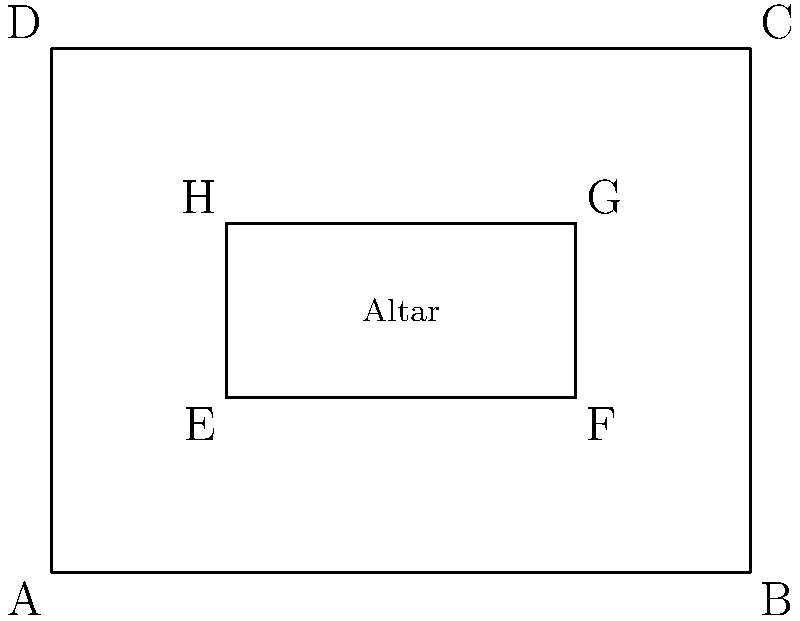In the floor plan of an ancient church, the outer rectangle ABCD represents the main sanctuary, while the inner rectangle EFGH outlines the altar area. If the sanctuary measures 40 feet by 30 feet, and the altar area is geometrically similar to the sanctuary with a scale factor of 1:2, what is the area of the altar in square feet? Let's approach this step-by-step:

1) First, we need to understand what "geometrically similar with a scale factor of 1:2" means. It implies that the altar's dimensions are half of the sanctuary's dimensions.

2) The sanctuary measures 40 feet by 30 feet. Let's calculate its area:
   $A_{sanctuary} = 40 \times 30 = 1200$ square feet

3) Now, let's determine the dimensions of the altar:
   Width of altar = $40 \div 2 = 20$ feet
   Length of altar = $30 \div 2 = 15$ feet

4) We can calculate the area of the altar:
   $A_{altar} = 20 \times 15 = 300$ square feet

5) We can verify this result using the scale factor. Since the altar is similar to the sanctuary with a scale factor of 1:2, its area should be $(1/2)^2 = 1/4$ of the sanctuary's area:

   $A_{altar} = A_{sanctuary} \times (1/2)^2 = 1200 \times 1/4 = 300$ square feet

This confirms our calculation.
Answer: 300 square feet 